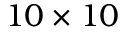Convert formula to latex. <formula><loc_0><loc_0><loc_500><loc_500>1 0 \times 1 0</formula> 